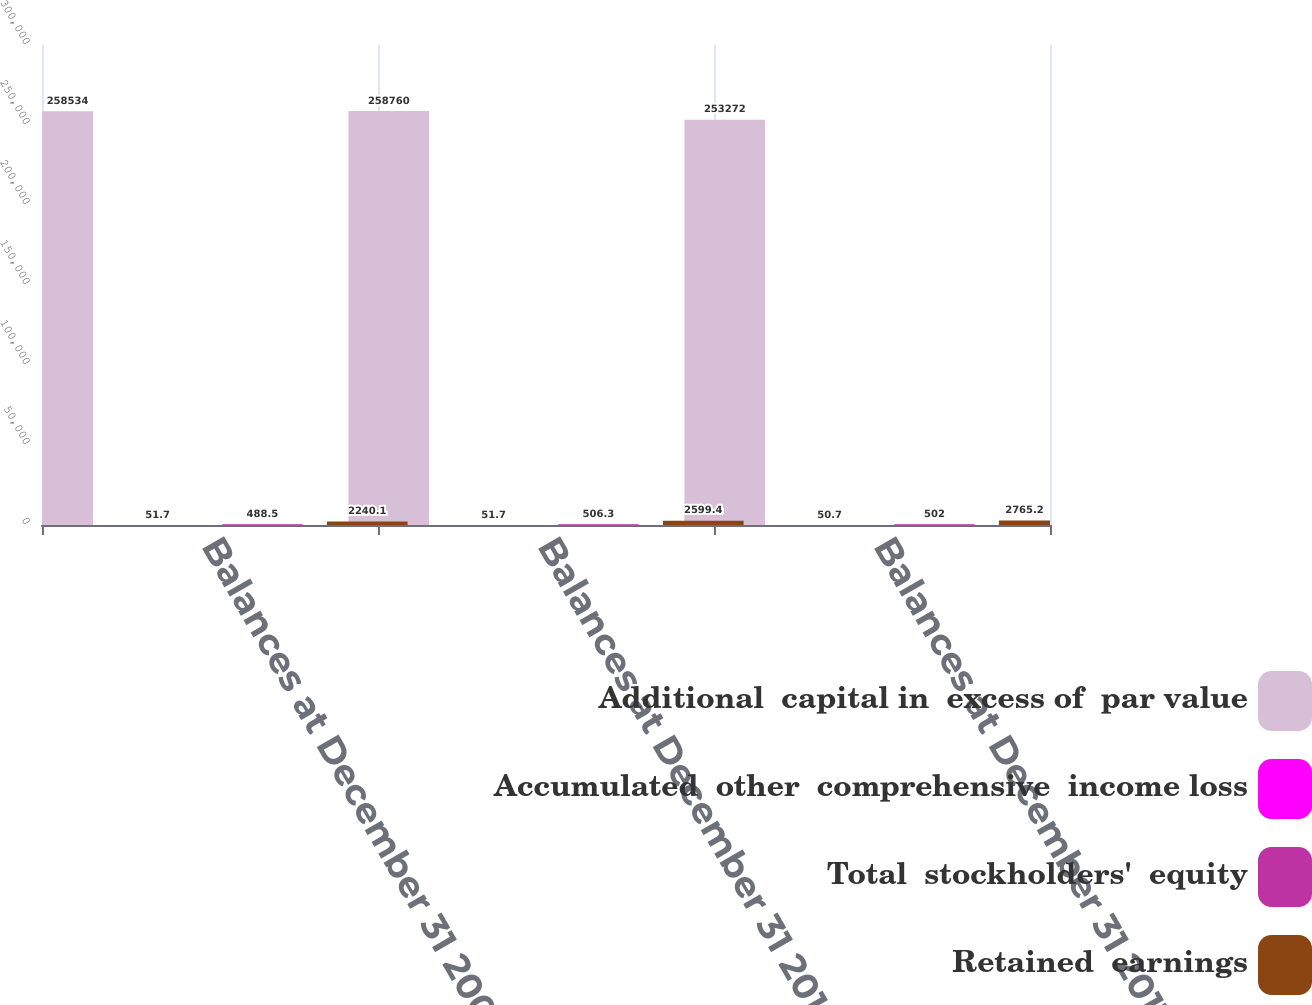Convert chart. <chart><loc_0><loc_0><loc_500><loc_500><stacked_bar_chart><ecel><fcel>Balances at December 31 2009<fcel>Balances at December 31 2010<fcel>Balances at December 31 2011<nl><fcel>Additional  capital in  excess of  par value<fcel>258534<fcel>258760<fcel>253272<nl><fcel>Accumulated  other  comprehensive  income loss<fcel>51.7<fcel>51.7<fcel>50.7<nl><fcel>Total  stockholders'  equity<fcel>488.5<fcel>506.3<fcel>502<nl><fcel>Retained  earnings<fcel>2240.1<fcel>2599.4<fcel>2765.2<nl></chart> 